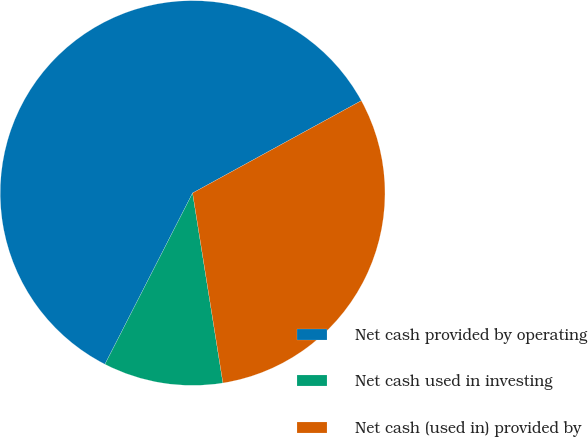<chart> <loc_0><loc_0><loc_500><loc_500><pie_chart><fcel>Net cash provided by operating<fcel>Net cash used in investing<fcel>Net cash (used in) provided by<nl><fcel>59.5%<fcel>10.05%<fcel>30.45%<nl></chart> 